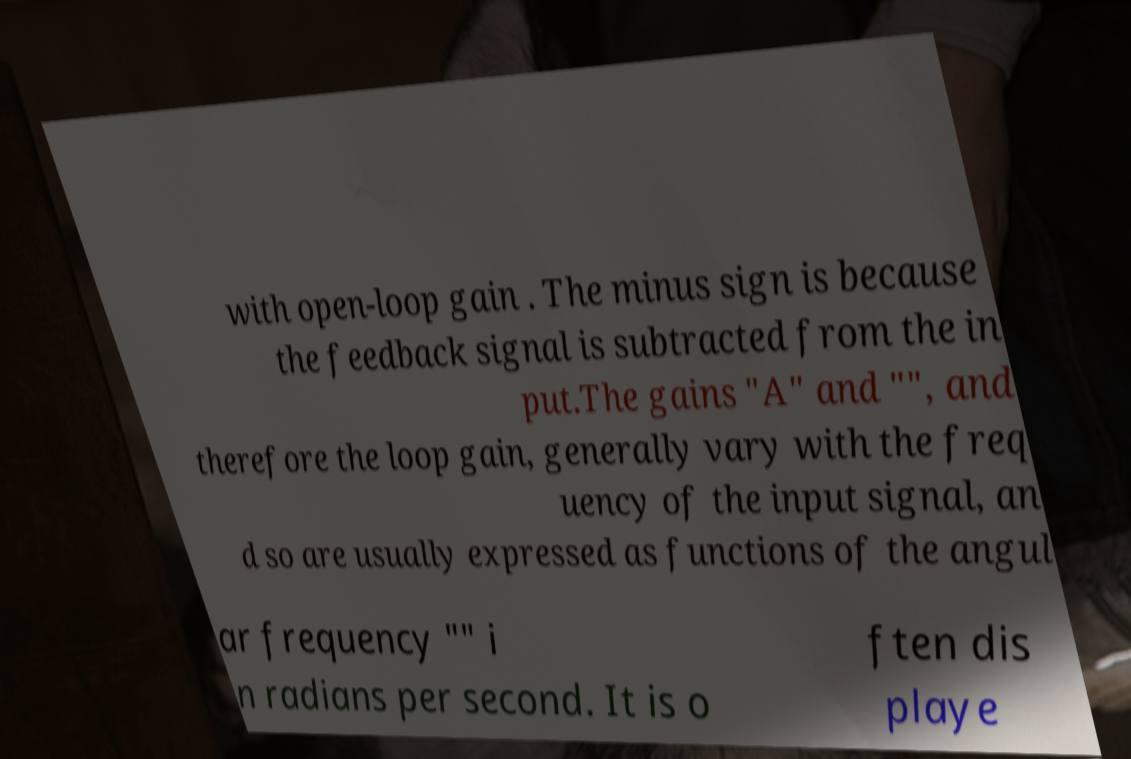Please identify and transcribe the text found in this image. with open-loop gain . The minus sign is because the feedback signal is subtracted from the in put.The gains "A" and "", and therefore the loop gain, generally vary with the freq uency of the input signal, an d so are usually expressed as functions of the angul ar frequency "" i n radians per second. It is o ften dis playe 